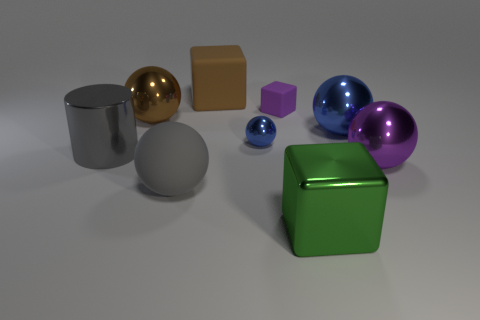Subtract all large brown metallic spheres. How many spheres are left? 4 Subtract all red cylinders. How many blue spheres are left? 2 Subtract all spheres. How many objects are left? 4 Subtract all brown cubes. How many cubes are left? 2 Subtract all brown cubes. Subtract all brown spheres. How many cubes are left? 2 Subtract all large green metal blocks. Subtract all blue things. How many objects are left? 6 Add 7 metallic cylinders. How many metallic cylinders are left? 8 Add 7 small metal blocks. How many small metal blocks exist? 7 Subtract 1 brown balls. How many objects are left? 8 Subtract 2 spheres. How many spheres are left? 3 